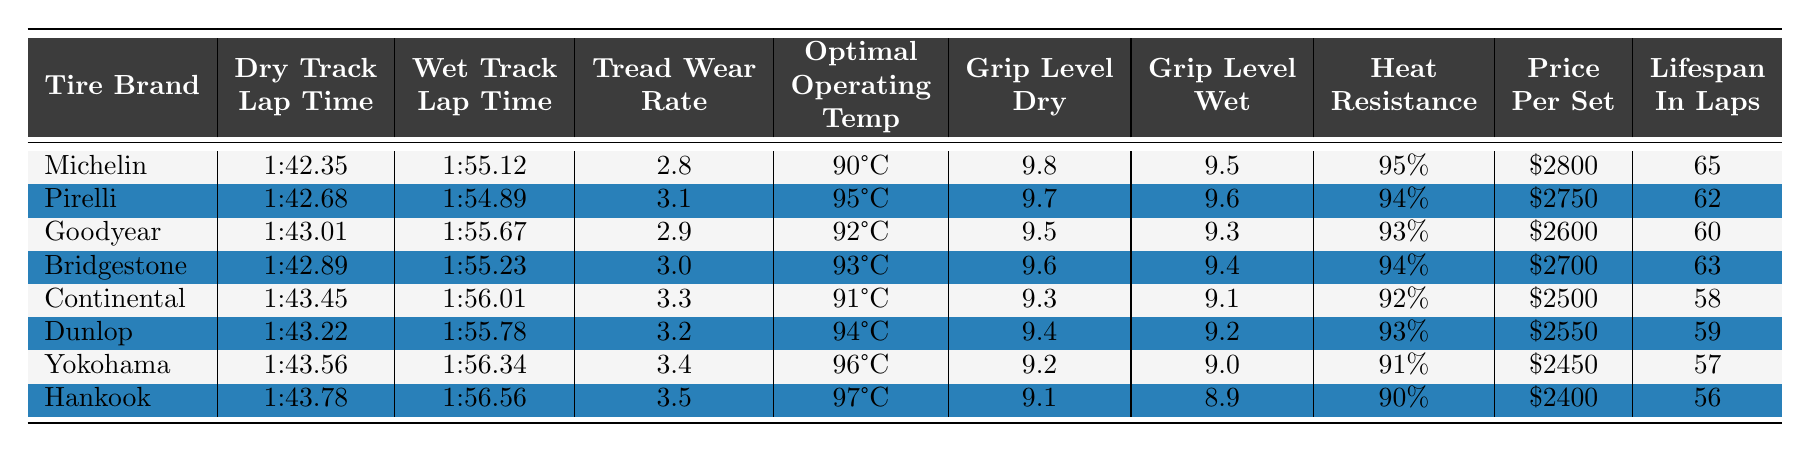What is the grip level of Michelin tires in dry conditions? The table lists the grip levels for each tire brand in dry conditions, which shows Michelin has a grip level of 9.8.
Answer: 9.8 Which tire brand has the lowest wet track lap time? By inspecting the wet track lap times, Pirelli has the lowest lap time of 1:54.89 among all the brands.
Answer: Pirelli What is the average tread wear rate of all the tire brands? To find the average, sum the tread wear rates (2.8 + 3.1 + 2.9 + 3.0 + 3.3 + 3.2 + 3.4 + 3.5 = 22.2) and divide by the number of brands (8). The average is 22.2/8 = 2.775.
Answer: 2.775 True or False: Goodyear has a better heat resistance than Continental. Goodyear's heat resistance is 93%, and Continental's is 92%. Since 93% is greater than 92%, the statement is true.
Answer: True Which tire brand performs best on dry tracks, and what is its lap time? The best performance is determined by the lowest dry track lap time. Michelin has the best lap time of 1:42.35 on dry tracks.
Answer: Michelin, 1:42.35 What is the price difference between the most and least expensive tire brands? The most expensive tire brand is Michelin at $2800 and the least expensive is Hankook at $2400. The price difference is $2800 - $2400 = $400.
Answer: $400 Which tire brand has the highest lifespan in laps, and how many laps can it endure? By examining the lifespan in laps, Michelin has the highest value at 65 laps, which is the maximum across all brands.
Answer: Michelin, 65 In wet conditions, how does the grip level of Pirelli compare to Hankook? Pirelli has a grip level of 9.6 in wet conditions, while Hankook has a grip level of 8.9. Pirelli's grip level is higher than Hankook's.
Answer: Pirelli has a higher grip level What is the total lifespan in laps for the tire brands that have a tread wear rate below 3.0? The tread wear rates below 3.0 are Michelin (2.8), Goodyear (2.9), and Bridgestone (3.0). Their lifespans are 65, 60, and 63 laps respectively. Sum these lifespans: 65 + 60 + 63 = 188 laps.
Answer: 188 laps What is the optimal operating temperature range for the tire brands with the best grip levels in dry conditions? The tire brands with the best grip levels are Michelin (9.8), Pirelli (9.7), and Bridgestone (9.6), whose optimal operating temperatures are 90°C, 95°C, and 93°C respectively. The temperatures range from 90°C to 95°C.
Answer: 90°C to 95°C 